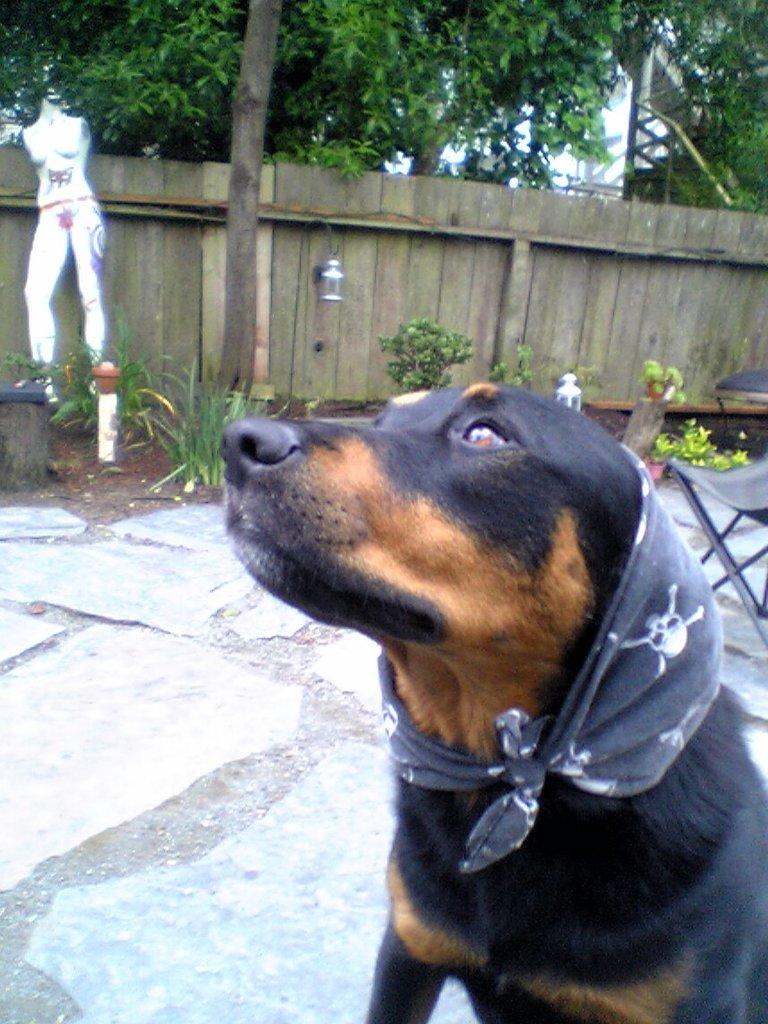What type of animal is in the image? There is a dog in the image. What is the dog holding or wearing? The dog has a cloth. What can be seen in the background of the image? There are plants, trees, and a light hung on a wooden fence in the background. Are there any other objects visible in the background? Yes, there are other objects visible in the background. Can you tell me how many frogs are sitting on the branch in the image? There is no branch or frog present in the image. What type of push is the dog performing in the image? The dog is not performing any push in the image; it is simply holding a cloth. 